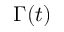<formula> <loc_0><loc_0><loc_500><loc_500>\Gamma ( t )</formula> 